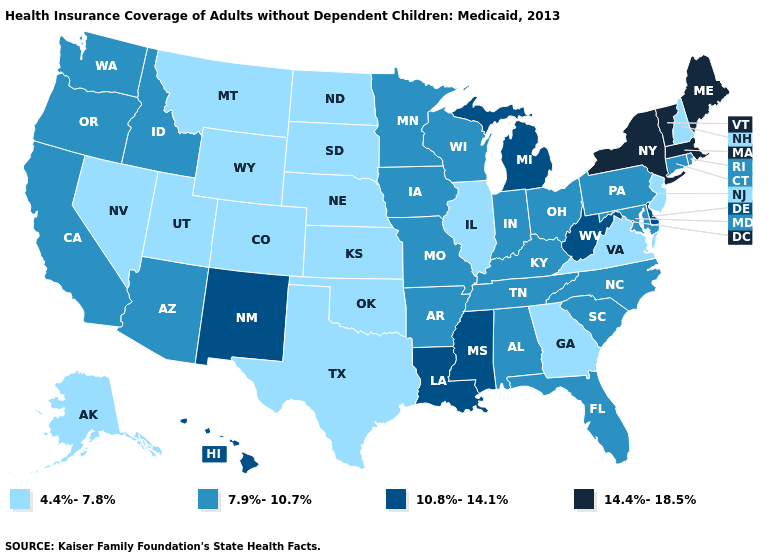Does Washington have a higher value than Virginia?
Quick response, please. Yes. Name the states that have a value in the range 10.8%-14.1%?
Concise answer only. Delaware, Hawaii, Louisiana, Michigan, Mississippi, New Mexico, West Virginia. Name the states that have a value in the range 4.4%-7.8%?
Keep it brief. Alaska, Colorado, Georgia, Illinois, Kansas, Montana, Nebraska, Nevada, New Hampshire, New Jersey, North Dakota, Oklahoma, South Dakota, Texas, Utah, Virginia, Wyoming. Name the states that have a value in the range 10.8%-14.1%?
Give a very brief answer. Delaware, Hawaii, Louisiana, Michigan, Mississippi, New Mexico, West Virginia. Name the states that have a value in the range 10.8%-14.1%?
Keep it brief. Delaware, Hawaii, Louisiana, Michigan, Mississippi, New Mexico, West Virginia. Does the map have missing data?
Be succinct. No. Does South Carolina have the lowest value in the USA?
Answer briefly. No. What is the value of Mississippi?
Be succinct. 10.8%-14.1%. Is the legend a continuous bar?
Be succinct. No. What is the value of Ohio?
Short answer required. 7.9%-10.7%. What is the value of Illinois?
Concise answer only. 4.4%-7.8%. Does Alaska have a higher value than New Jersey?
Concise answer only. No. What is the value of Kansas?
Short answer required. 4.4%-7.8%. Name the states that have a value in the range 4.4%-7.8%?
Short answer required. Alaska, Colorado, Georgia, Illinois, Kansas, Montana, Nebraska, Nevada, New Hampshire, New Jersey, North Dakota, Oklahoma, South Dakota, Texas, Utah, Virginia, Wyoming. Among the states that border Illinois , which have the lowest value?
Short answer required. Indiana, Iowa, Kentucky, Missouri, Wisconsin. 